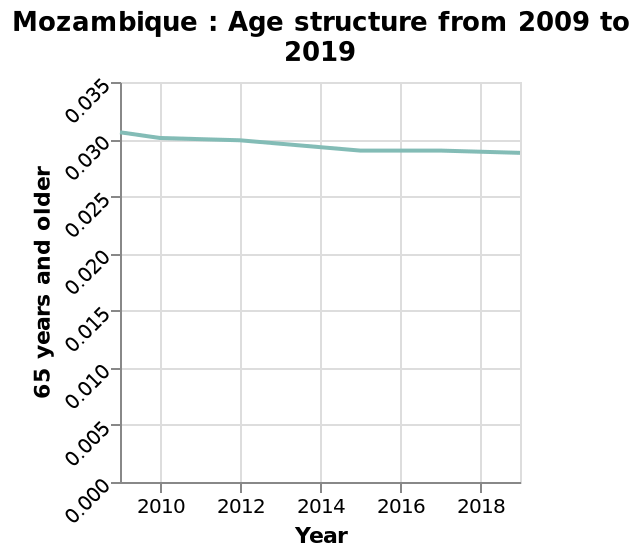<image>
Offer a thorough analysis of the image. on average, over a 10 year period the number of above 65 years has declined 0.003. 0.0015 each 5 years respectively. Each year there has been either a decline or levelling in the overall number of less than 65s. There has been no increase in the number of over 65 years old. From these trends we can deduce that the overall population of over 65s is reducing and the number of under 65s is increasing at the rate 0.003 per 10 years or 0.0003 per year. Has there been any increase in the number of people above 65 years old?  No, there has been no increase in the number of people above 65 years old. What does the y-axis represent? The y-axis represents the percentage of people aged 65 years and older in Mozambique, ranging from 0.000 to 0.035. What is the highest value shown on the y-axis? The highest value shown on the y-axis is 0.035, indicating the highest percentage of people aged 65 years and older in Mozambique during the given time period. What is the range of the x-axis? The x-axis measures the years from 2010 to 2018. 